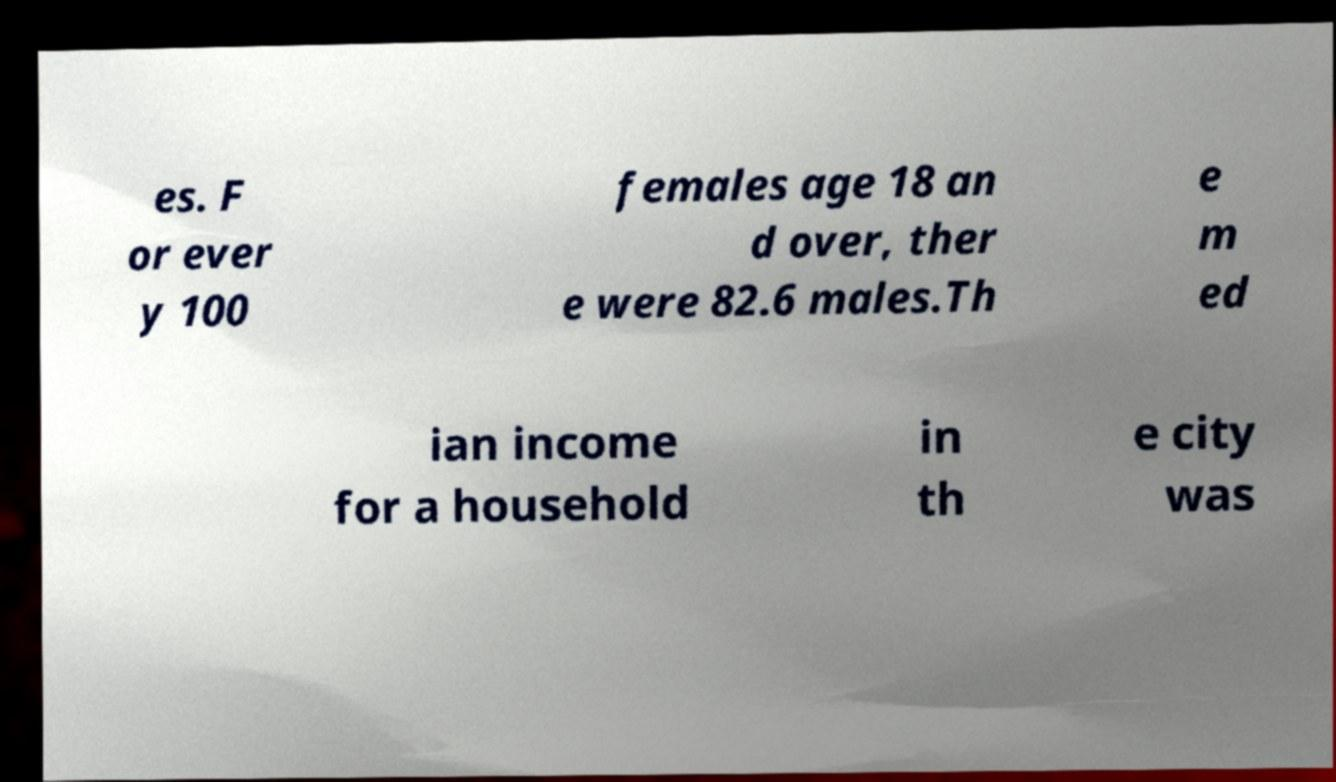Can you read and provide the text displayed in the image?This photo seems to have some interesting text. Can you extract and type it out for me? es. F or ever y 100 females age 18 an d over, ther e were 82.6 males.Th e m ed ian income for a household in th e city was 